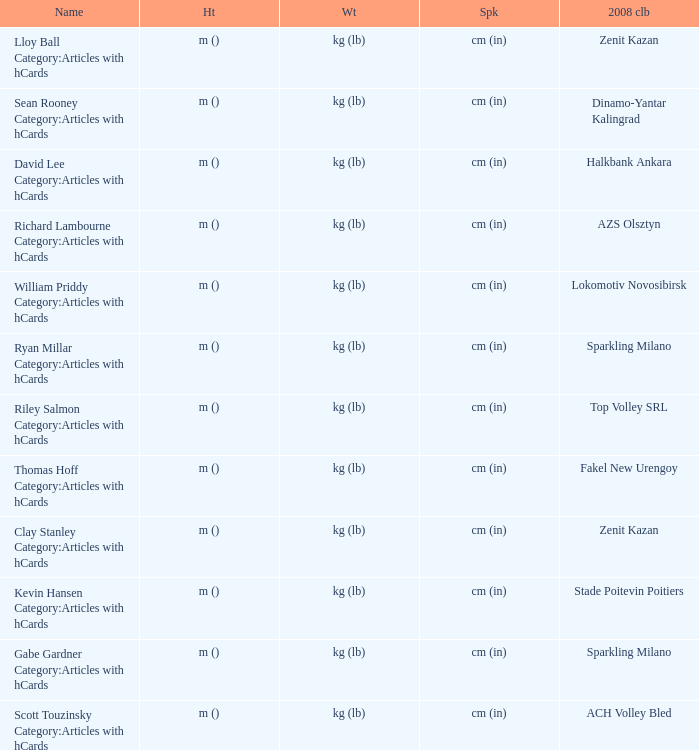Would you mind parsing the complete table? {'header': ['Name', 'Ht', 'Wt', 'Spk', '2008 clb'], 'rows': [['Lloy Ball Category:Articles with hCards', 'm ()', 'kg (lb)', 'cm (in)', 'Zenit Kazan'], ['Sean Rooney Category:Articles with hCards', 'm ()', 'kg (lb)', 'cm (in)', 'Dinamo-Yantar Kalingrad'], ['David Lee Category:Articles with hCards', 'm ()', 'kg (lb)', 'cm (in)', 'Halkbank Ankara'], ['Richard Lambourne Category:Articles with hCards', 'm ()', 'kg (lb)', 'cm (in)', 'AZS Olsztyn'], ['William Priddy Category:Articles with hCards', 'm ()', 'kg (lb)', 'cm (in)', 'Lokomotiv Novosibirsk'], ['Ryan Millar Category:Articles with hCards', 'm ()', 'kg (lb)', 'cm (in)', 'Sparkling Milano'], ['Riley Salmon Category:Articles with hCards', 'm ()', 'kg (lb)', 'cm (in)', 'Top Volley SRL'], ['Thomas Hoff Category:Articles with hCards', 'm ()', 'kg (lb)', 'cm (in)', 'Fakel New Urengoy'], ['Clay Stanley Category:Articles with hCards', 'm ()', 'kg (lb)', 'cm (in)', 'Zenit Kazan'], ['Kevin Hansen Category:Articles with hCards', 'm ()', 'kg (lb)', 'cm (in)', 'Stade Poitevin Poitiers'], ['Gabe Gardner Category:Articles with hCards', 'm ()', 'kg (lb)', 'cm (in)', 'Sparkling Milano'], ['Scott Touzinsky Category:Articles with hCards', 'm ()', 'kg (lb)', 'cm (in)', 'ACH Volley Bled']]} What is the spike for the 2008 club of Lokomotiv Novosibirsk? Cm (in). 